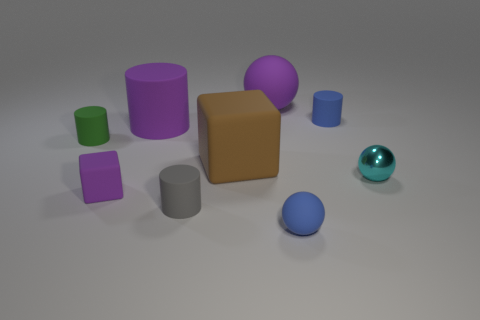What color is the rubber thing that is behind the small blue matte object behind the tiny sphere in front of the purple rubber block?
Give a very brief answer. Purple. Is the material of the big purple object left of the brown rubber object the same as the small sphere that is behind the gray cylinder?
Offer a terse response. No. What shape is the small blue thing behind the small cyan shiny ball?
Provide a succinct answer. Cylinder. How many objects are either yellow metal spheres or tiny matte cylinders that are on the left side of the blue cylinder?
Your answer should be compact. 2. Is the material of the large cube the same as the tiny cyan ball?
Keep it short and to the point. No. Is the number of matte cubes that are behind the purple cylinder the same as the number of small purple rubber objects that are behind the green rubber object?
Your answer should be very brief. Yes. There is a small green rubber cylinder; how many big rubber things are in front of it?
Give a very brief answer. 1. How many things are small matte blocks or small cyan metallic cubes?
Provide a succinct answer. 1. How many blue cylinders are the same size as the gray rubber thing?
Provide a succinct answer. 1. What is the shape of the object that is to the left of the purple matte object in front of the green rubber object?
Your answer should be very brief. Cylinder. 